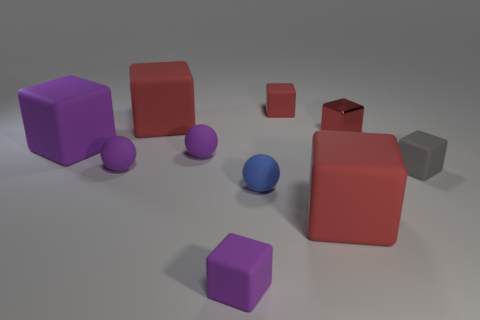Subtract all red balls. How many red cubes are left? 4 Subtract all gray cubes. How many cubes are left? 6 Subtract all purple cubes. How many cubes are left? 5 Subtract all yellow cubes. Subtract all red balls. How many cubes are left? 7 Subtract all blocks. How many objects are left? 3 Subtract all purple rubber spheres. Subtract all purple cubes. How many objects are left? 6 Add 5 gray objects. How many gray objects are left? 6 Add 3 purple balls. How many purple balls exist? 5 Subtract 0 cyan blocks. How many objects are left? 10 